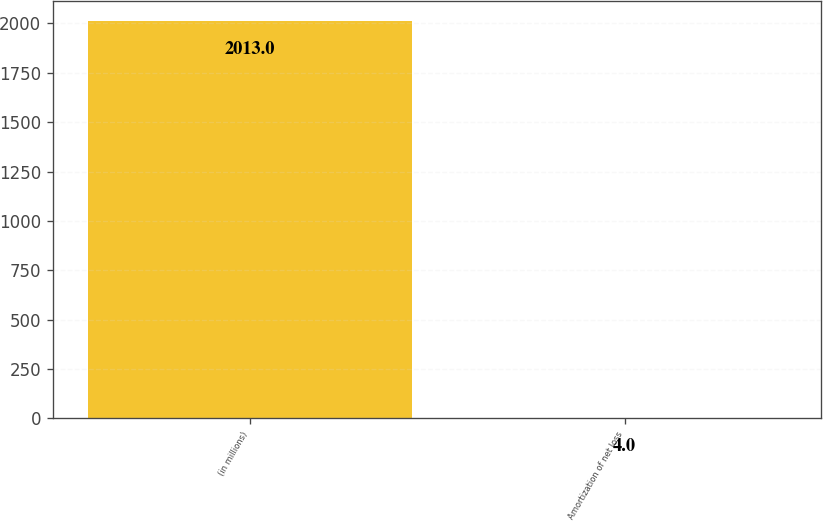Convert chart. <chart><loc_0><loc_0><loc_500><loc_500><bar_chart><fcel>(in millions)<fcel>Amortization of net loss<nl><fcel>2013<fcel>4<nl></chart> 